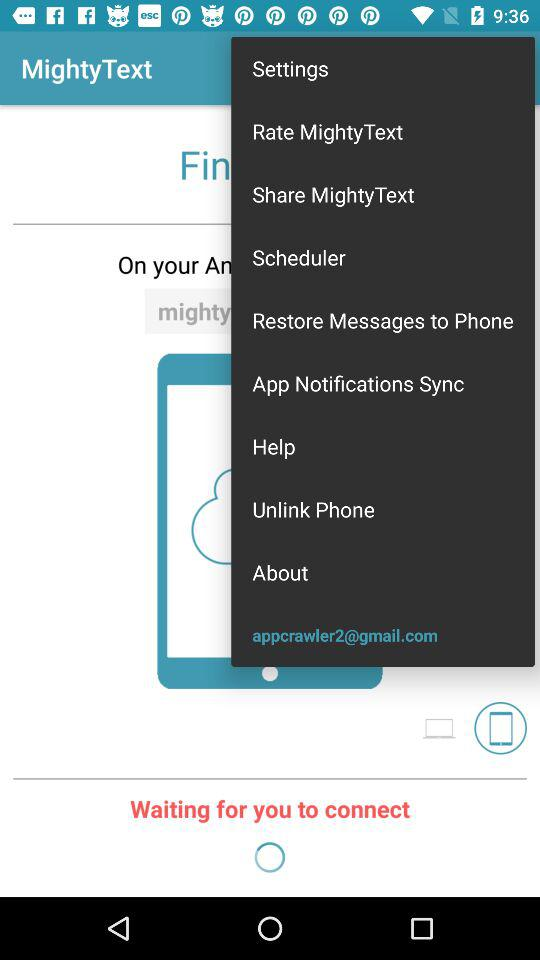What is the gmail account? The gmail account is appcrawler2@gmail.com. 